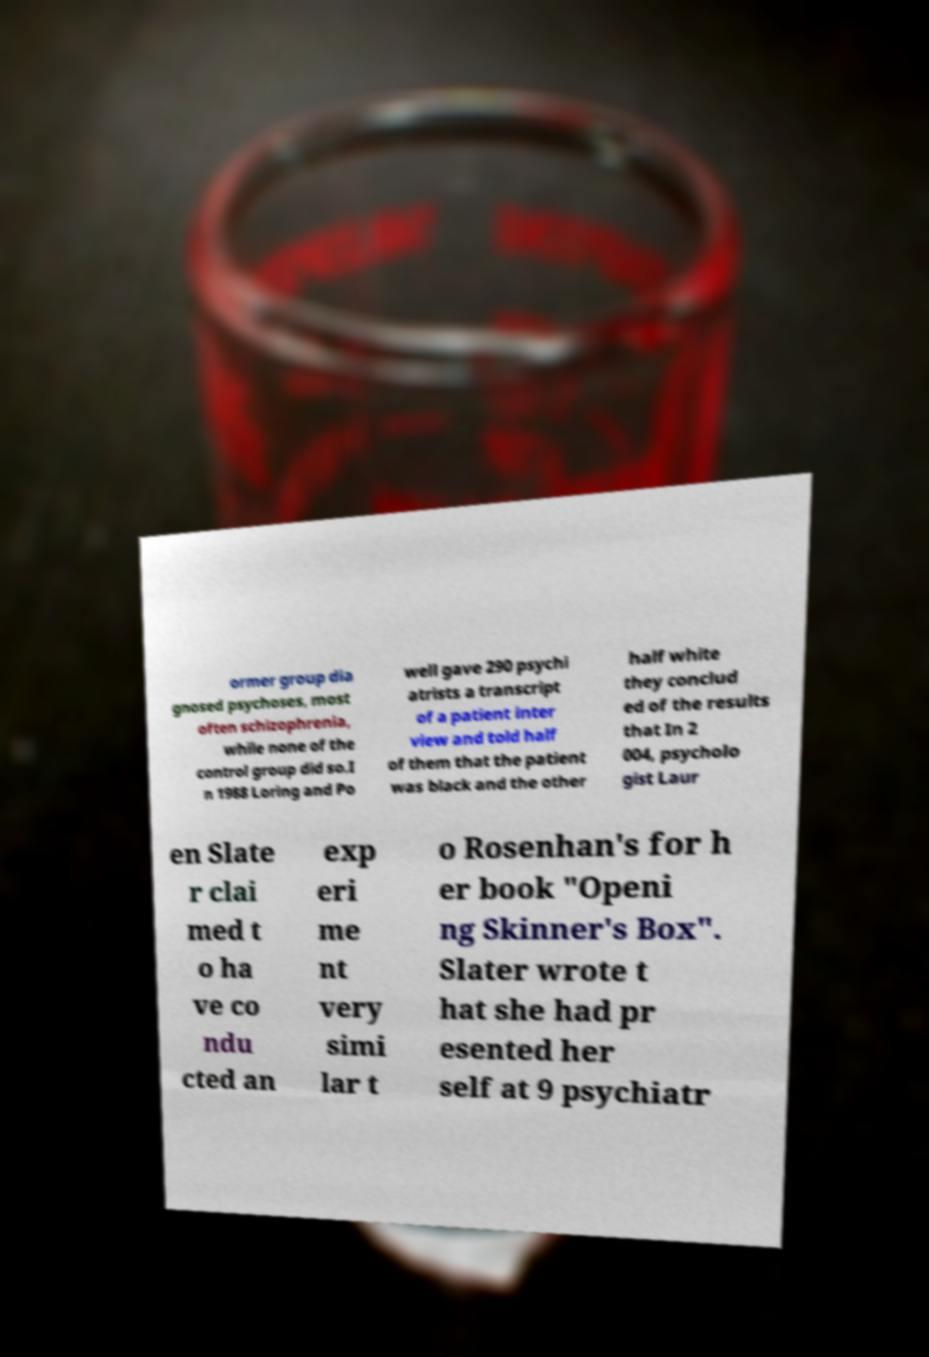Please read and relay the text visible in this image. What does it say? ormer group dia gnosed psychoses, most often schizophrenia, while none of the control group did so.I n 1988 Loring and Po well gave 290 psychi atrists a transcript of a patient inter view and told half of them that the patient was black and the other half white they conclud ed of the results that In 2 004, psycholo gist Laur en Slate r clai med t o ha ve co ndu cted an exp eri me nt very simi lar t o Rosenhan's for h er book "Openi ng Skinner's Box". Slater wrote t hat she had pr esented her self at 9 psychiatr 